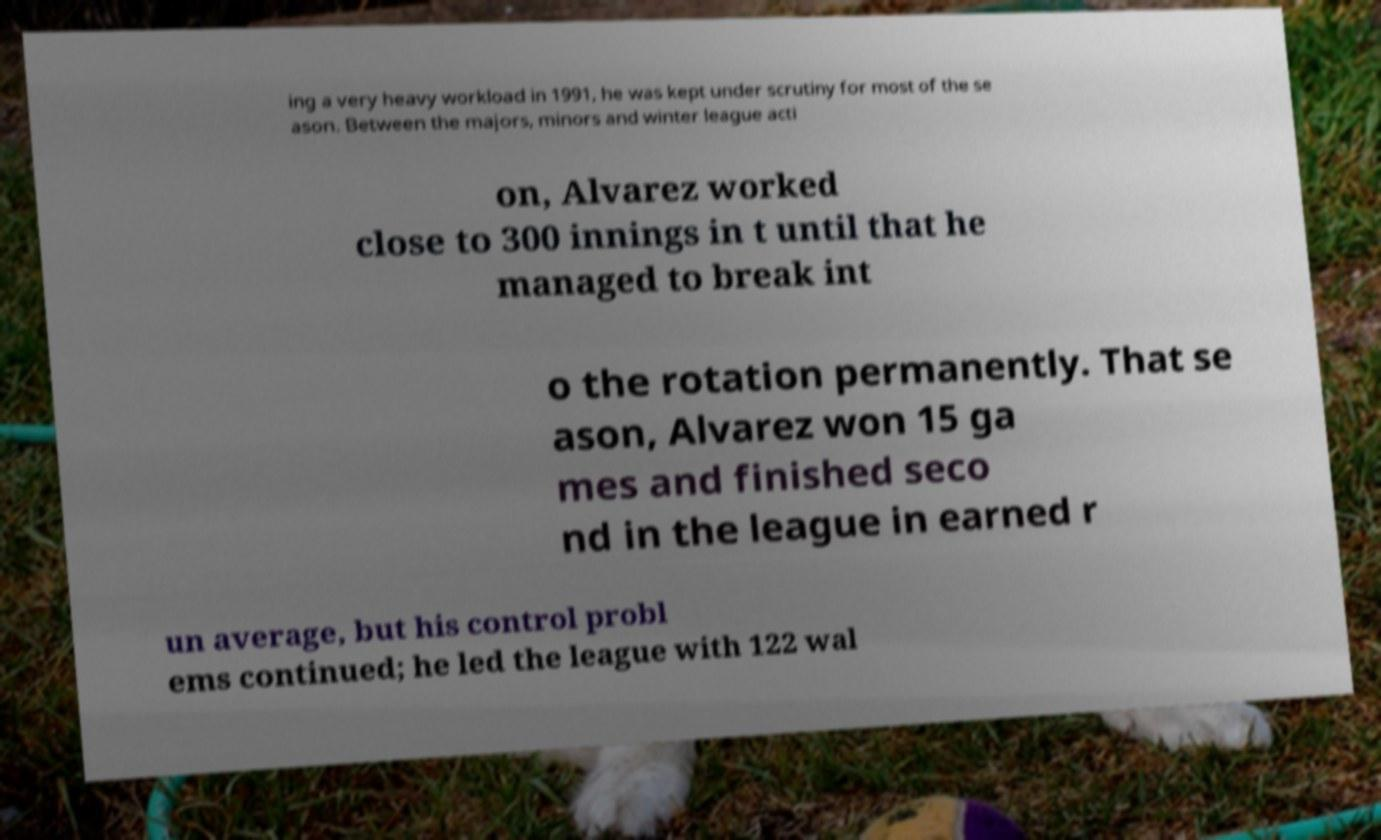Can you accurately transcribe the text from the provided image for me? ing a very heavy workload in 1991, he was kept under scrutiny for most of the se ason. Between the majors, minors and winter league acti on, Alvarez worked close to 300 innings in t until that he managed to break int o the rotation permanently. That se ason, Alvarez won 15 ga mes and finished seco nd in the league in earned r un average, but his control probl ems continued; he led the league with 122 wal 